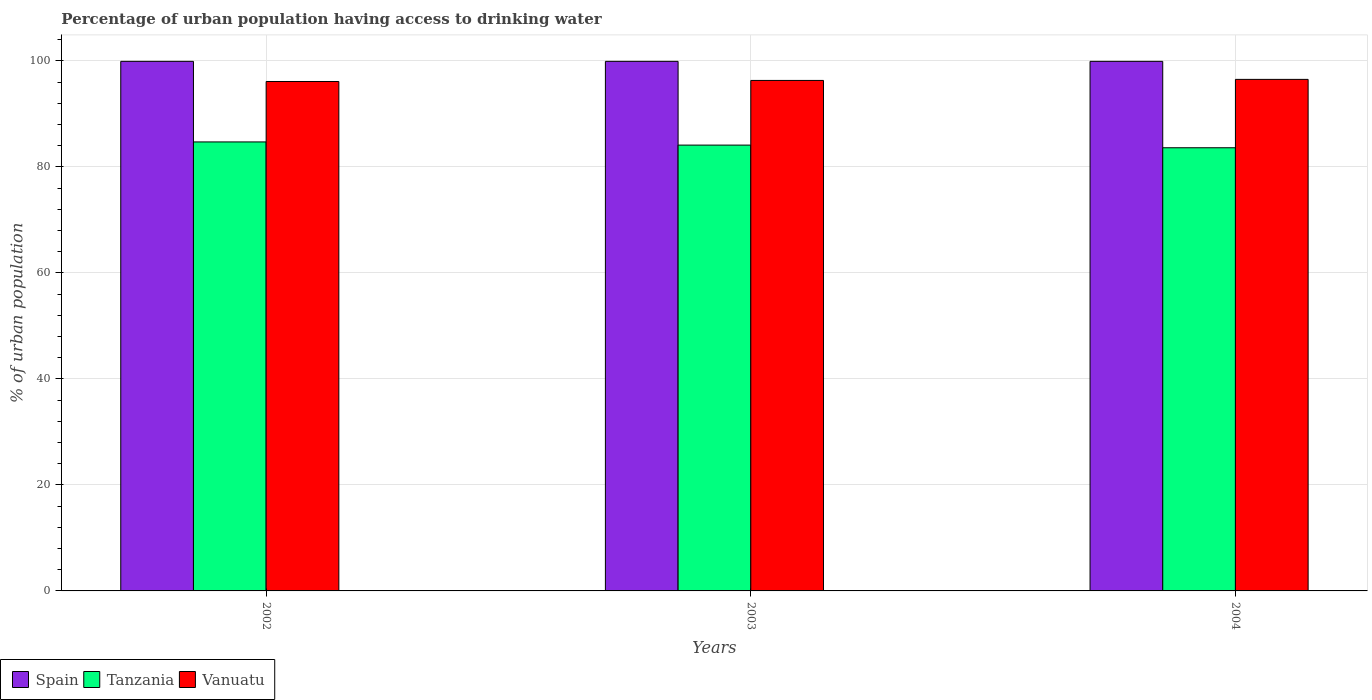How many different coloured bars are there?
Your answer should be compact. 3. How many groups of bars are there?
Offer a very short reply. 3. Are the number of bars on each tick of the X-axis equal?
Provide a succinct answer. Yes. How many bars are there on the 1st tick from the right?
Offer a terse response. 3. What is the label of the 1st group of bars from the left?
Provide a short and direct response. 2002. In how many cases, is the number of bars for a given year not equal to the number of legend labels?
Make the answer very short. 0. What is the percentage of urban population having access to drinking water in Tanzania in 2003?
Make the answer very short. 84.1. Across all years, what is the maximum percentage of urban population having access to drinking water in Vanuatu?
Your answer should be very brief. 96.5. Across all years, what is the minimum percentage of urban population having access to drinking water in Spain?
Your response must be concise. 99.9. In which year was the percentage of urban population having access to drinking water in Spain minimum?
Your answer should be very brief. 2002. What is the total percentage of urban population having access to drinking water in Tanzania in the graph?
Offer a terse response. 252.4. What is the difference between the percentage of urban population having access to drinking water in Vanuatu in 2002 and the percentage of urban population having access to drinking water in Spain in 2004?
Offer a terse response. -3.8. What is the average percentage of urban population having access to drinking water in Vanuatu per year?
Your answer should be compact. 96.3. In the year 2002, what is the difference between the percentage of urban population having access to drinking water in Vanuatu and percentage of urban population having access to drinking water in Spain?
Provide a short and direct response. -3.8. In how many years, is the percentage of urban population having access to drinking water in Spain greater than 12 %?
Give a very brief answer. 3. What is the ratio of the percentage of urban population having access to drinking water in Spain in 2002 to that in 2004?
Your response must be concise. 1. What is the difference between the highest and the lowest percentage of urban population having access to drinking water in Tanzania?
Give a very brief answer. 1.1. What does the 1st bar from the left in 2003 represents?
Offer a very short reply. Spain. What does the 1st bar from the right in 2002 represents?
Provide a short and direct response. Vanuatu. Is it the case that in every year, the sum of the percentage of urban population having access to drinking water in Vanuatu and percentage of urban population having access to drinking water in Tanzania is greater than the percentage of urban population having access to drinking water in Spain?
Your response must be concise. Yes. How many bars are there?
Give a very brief answer. 9. What is the difference between two consecutive major ticks on the Y-axis?
Your response must be concise. 20. Are the values on the major ticks of Y-axis written in scientific E-notation?
Offer a very short reply. No. Does the graph contain any zero values?
Provide a succinct answer. No. Where does the legend appear in the graph?
Keep it short and to the point. Bottom left. How many legend labels are there?
Provide a succinct answer. 3. What is the title of the graph?
Provide a short and direct response. Percentage of urban population having access to drinking water. Does "St. Lucia" appear as one of the legend labels in the graph?
Your answer should be very brief. No. What is the label or title of the X-axis?
Offer a very short reply. Years. What is the label or title of the Y-axis?
Keep it short and to the point. % of urban population. What is the % of urban population in Spain in 2002?
Ensure brevity in your answer.  99.9. What is the % of urban population in Tanzania in 2002?
Keep it short and to the point. 84.7. What is the % of urban population of Vanuatu in 2002?
Give a very brief answer. 96.1. What is the % of urban population in Spain in 2003?
Your answer should be very brief. 99.9. What is the % of urban population of Tanzania in 2003?
Offer a very short reply. 84.1. What is the % of urban population in Vanuatu in 2003?
Make the answer very short. 96.3. What is the % of urban population of Spain in 2004?
Give a very brief answer. 99.9. What is the % of urban population of Tanzania in 2004?
Ensure brevity in your answer.  83.6. What is the % of urban population of Vanuatu in 2004?
Offer a terse response. 96.5. Across all years, what is the maximum % of urban population of Spain?
Offer a very short reply. 99.9. Across all years, what is the maximum % of urban population in Tanzania?
Your answer should be very brief. 84.7. Across all years, what is the maximum % of urban population of Vanuatu?
Make the answer very short. 96.5. Across all years, what is the minimum % of urban population in Spain?
Offer a very short reply. 99.9. Across all years, what is the minimum % of urban population in Tanzania?
Your answer should be compact. 83.6. Across all years, what is the minimum % of urban population in Vanuatu?
Your response must be concise. 96.1. What is the total % of urban population of Spain in the graph?
Offer a terse response. 299.7. What is the total % of urban population in Tanzania in the graph?
Provide a succinct answer. 252.4. What is the total % of urban population in Vanuatu in the graph?
Provide a short and direct response. 288.9. What is the difference between the % of urban population of Tanzania in 2002 and that in 2003?
Offer a terse response. 0.6. What is the difference between the % of urban population of Tanzania in 2002 and that in 2004?
Provide a succinct answer. 1.1. What is the difference between the % of urban population in Spain in 2003 and that in 2004?
Keep it short and to the point. 0. What is the difference between the % of urban population in Tanzania in 2003 and that in 2004?
Provide a short and direct response. 0.5. What is the difference between the % of urban population of Vanuatu in 2003 and that in 2004?
Keep it short and to the point. -0.2. What is the difference between the % of urban population in Tanzania in 2002 and the % of urban population in Vanuatu in 2003?
Your response must be concise. -11.6. What is the difference between the % of urban population of Tanzania in 2002 and the % of urban population of Vanuatu in 2004?
Make the answer very short. -11.8. What is the difference between the % of urban population in Spain in 2003 and the % of urban population in Vanuatu in 2004?
Your answer should be very brief. 3.4. What is the difference between the % of urban population in Tanzania in 2003 and the % of urban population in Vanuatu in 2004?
Offer a very short reply. -12.4. What is the average % of urban population of Spain per year?
Offer a very short reply. 99.9. What is the average % of urban population of Tanzania per year?
Ensure brevity in your answer.  84.13. What is the average % of urban population of Vanuatu per year?
Offer a very short reply. 96.3. In the year 2002, what is the difference between the % of urban population in Spain and % of urban population in Tanzania?
Make the answer very short. 15.2. In the year 2002, what is the difference between the % of urban population of Tanzania and % of urban population of Vanuatu?
Your answer should be compact. -11.4. In the year 2003, what is the difference between the % of urban population in Spain and % of urban population in Tanzania?
Ensure brevity in your answer.  15.8. In the year 2003, what is the difference between the % of urban population of Spain and % of urban population of Vanuatu?
Your answer should be compact. 3.6. In the year 2004, what is the difference between the % of urban population of Spain and % of urban population of Tanzania?
Ensure brevity in your answer.  16.3. In the year 2004, what is the difference between the % of urban population of Spain and % of urban population of Vanuatu?
Offer a very short reply. 3.4. What is the ratio of the % of urban population in Tanzania in 2002 to that in 2003?
Your response must be concise. 1.01. What is the ratio of the % of urban population in Tanzania in 2002 to that in 2004?
Give a very brief answer. 1.01. What is the ratio of the % of urban population of Vanuatu in 2002 to that in 2004?
Your answer should be compact. 1. What is the ratio of the % of urban population of Vanuatu in 2003 to that in 2004?
Offer a very short reply. 1. What is the difference between the highest and the second highest % of urban population in Vanuatu?
Offer a very short reply. 0.2. What is the difference between the highest and the lowest % of urban population in Tanzania?
Your answer should be compact. 1.1. What is the difference between the highest and the lowest % of urban population in Vanuatu?
Provide a short and direct response. 0.4. 